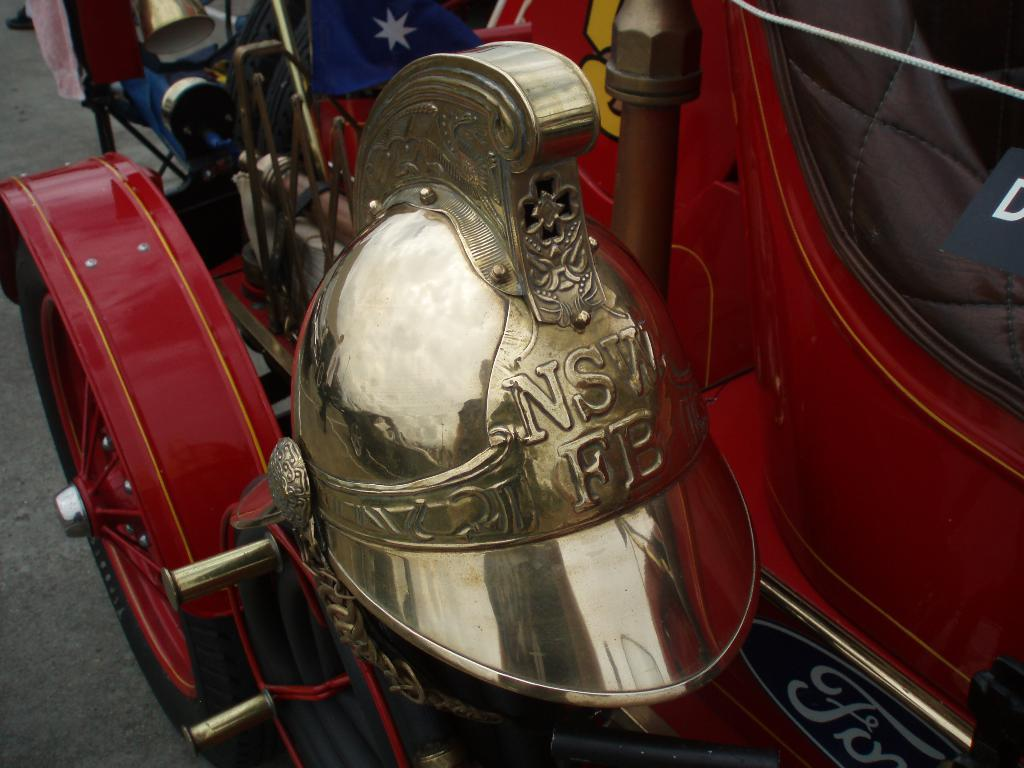What type of object is the main subject in the image? There is a gold-colored roman warrior hat mask in the image. What else can be seen in the image besides the hat mask? There is a red vehicle and a wheel in the image. What time is the vehicle adjusting its country in the image? There is no indication in the image that the vehicle is adjusting its country or that time is a factor. 